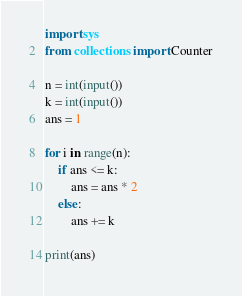Convert code to text. <code><loc_0><loc_0><loc_500><loc_500><_Python_>import sys
from collections import Counter

n = int(input())
k = int(input())
ans = 1

for i in range(n):
    if ans <= k:
        ans = ans * 2
    else:
        ans += k

print(ans)
</code> 